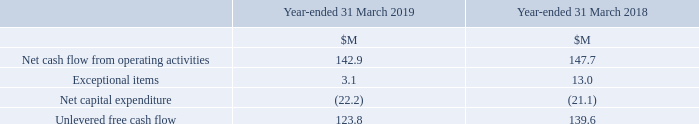5 Alternative Performance Measures (“APM’s”) continued
Unlevered Free Cash Flow
Unlevered free cash flow represents net cash flow from operating activities adjusted for exceptional items and net capital expenditure. Unlevered free cash flow provides an understanding of the Group’s cash generation and is a supplemental measure of liquidity in respect of the Group’s operations without the distortions of exceptional and other non-operating items.
What does unlevered free cash flow represent? Net cash flow from operating activities adjusted for exceptional items and net capital expenditure. What does unlevered free cash flow provide? An understanding of the group’s cash generation and is a supplemental measure of liquidity in respect of the group’s operations without the distortions of exceptional and other non-operating items. What are the components in the table used to calculate the unlevered free cash flow? Net cash flow from operating activities, exceptional items, net capital expenditure. In which year was the amount of Net cash flow from operating activities larger? 147.7>142.9
Answer: 2018. What was the change in exceptional items in 2019 from 2018?
Answer scale should be: million. 3.1-13.0
Answer: -9.9. What was the percentage change in exceptional items in 2019 from 2018?
Answer scale should be: percent. (3.1-13.0)/13.0
Answer: -76.15. 